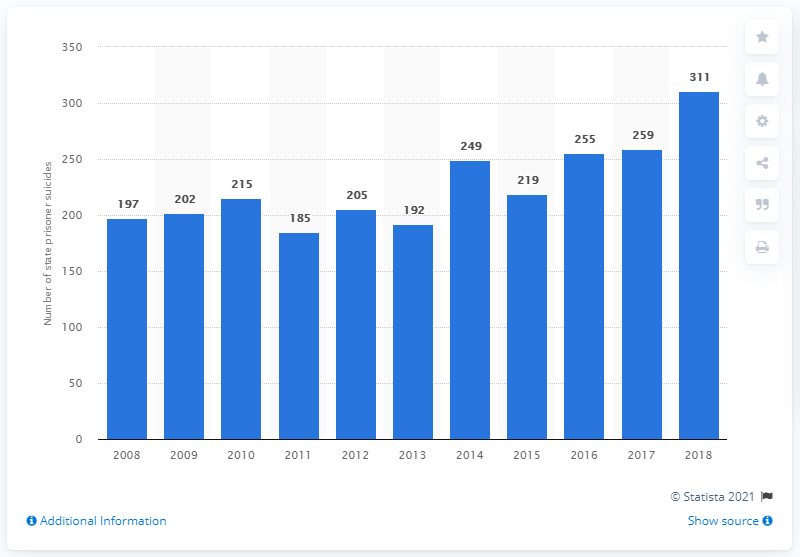Mention a couple of crucial points in this snapshot. In 2018, 259 state prison inmates died by suicide. In 2018, a total of 311 state prison inmates died by suicide. 